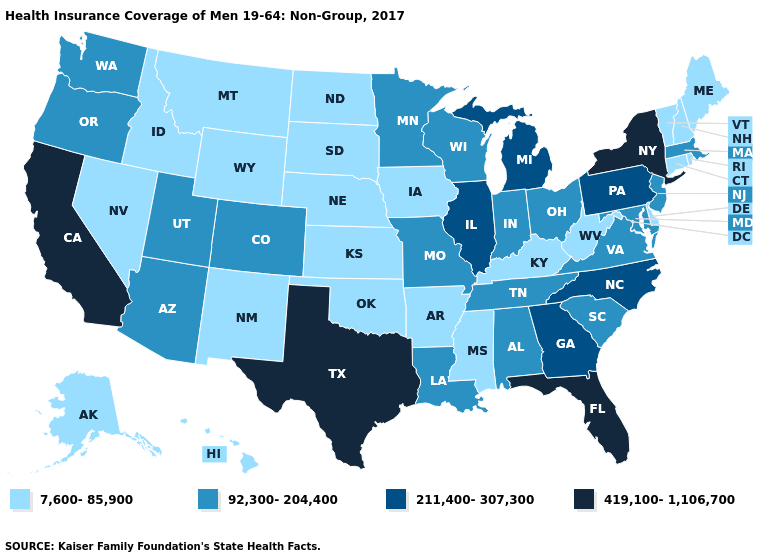Does New Mexico have the same value as Montana?
Keep it brief. Yes. Name the states that have a value in the range 92,300-204,400?
Write a very short answer. Alabama, Arizona, Colorado, Indiana, Louisiana, Maryland, Massachusetts, Minnesota, Missouri, New Jersey, Ohio, Oregon, South Carolina, Tennessee, Utah, Virginia, Washington, Wisconsin. Which states have the lowest value in the West?
Give a very brief answer. Alaska, Hawaii, Idaho, Montana, Nevada, New Mexico, Wyoming. Does Texas have the highest value in the South?
Short answer required. Yes. What is the value of Utah?
Quick response, please. 92,300-204,400. Does Kansas have the highest value in the USA?
Concise answer only. No. What is the value of Idaho?
Give a very brief answer. 7,600-85,900. Which states have the highest value in the USA?
Quick response, please. California, Florida, New York, Texas. Name the states that have a value in the range 92,300-204,400?
Answer briefly. Alabama, Arizona, Colorado, Indiana, Louisiana, Maryland, Massachusetts, Minnesota, Missouri, New Jersey, Ohio, Oregon, South Carolina, Tennessee, Utah, Virginia, Washington, Wisconsin. What is the value of Illinois?
Answer briefly. 211,400-307,300. What is the value of North Dakota?
Write a very short answer. 7,600-85,900. What is the value of California?
Be succinct. 419,100-1,106,700. Name the states that have a value in the range 7,600-85,900?
Write a very short answer. Alaska, Arkansas, Connecticut, Delaware, Hawaii, Idaho, Iowa, Kansas, Kentucky, Maine, Mississippi, Montana, Nebraska, Nevada, New Hampshire, New Mexico, North Dakota, Oklahoma, Rhode Island, South Dakota, Vermont, West Virginia, Wyoming. What is the value of Texas?
Be succinct. 419,100-1,106,700. What is the value of Wyoming?
Write a very short answer. 7,600-85,900. 